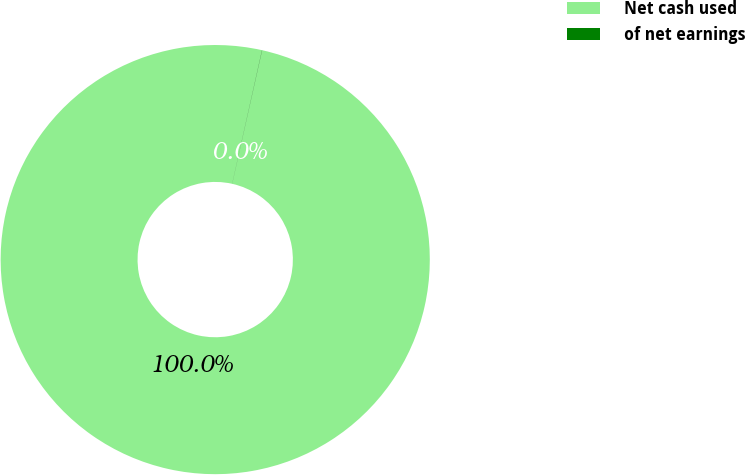<chart> <loc_0><loc_0><loc_500><loc_500><pie_chart><fcel>Net cash used<fcel>of net earnings<nl><fcel>99.98%<fcel>0.02%<nl></chart> 